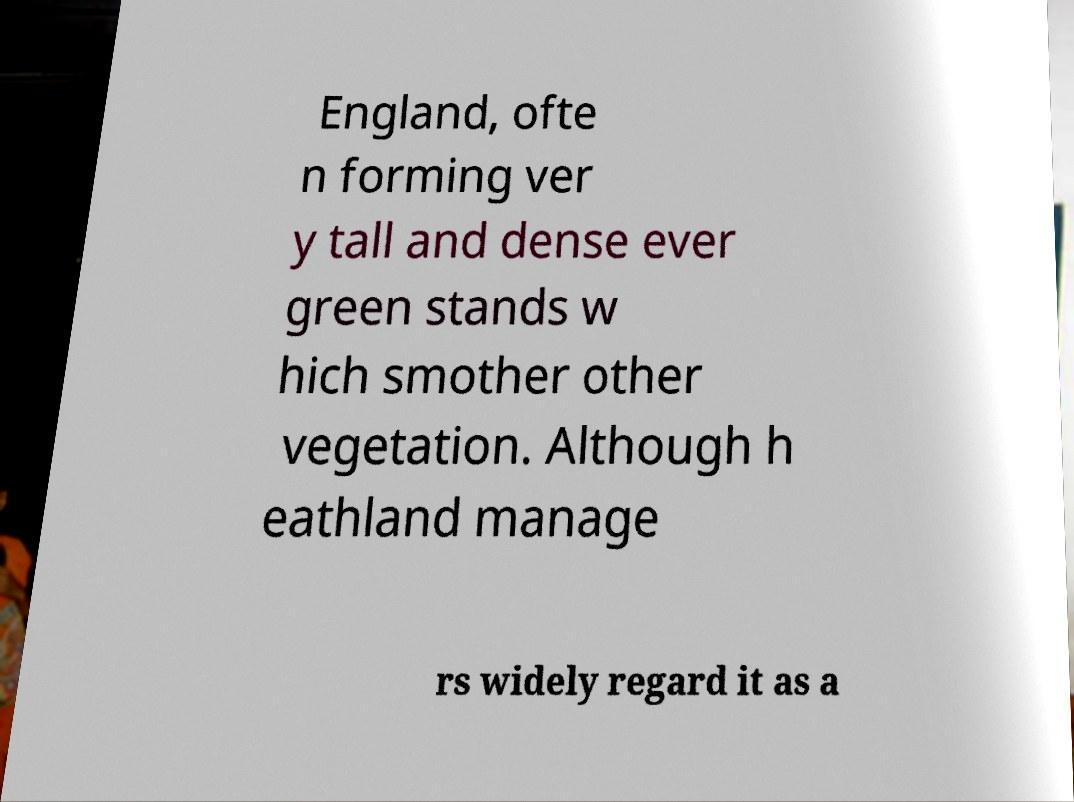Please identify and transcribe the text found in this image. England, ofte n forming ver y tall and dense ever green stands w hich smother other vegetation. Although h eathland manage rs widely regard it as a 